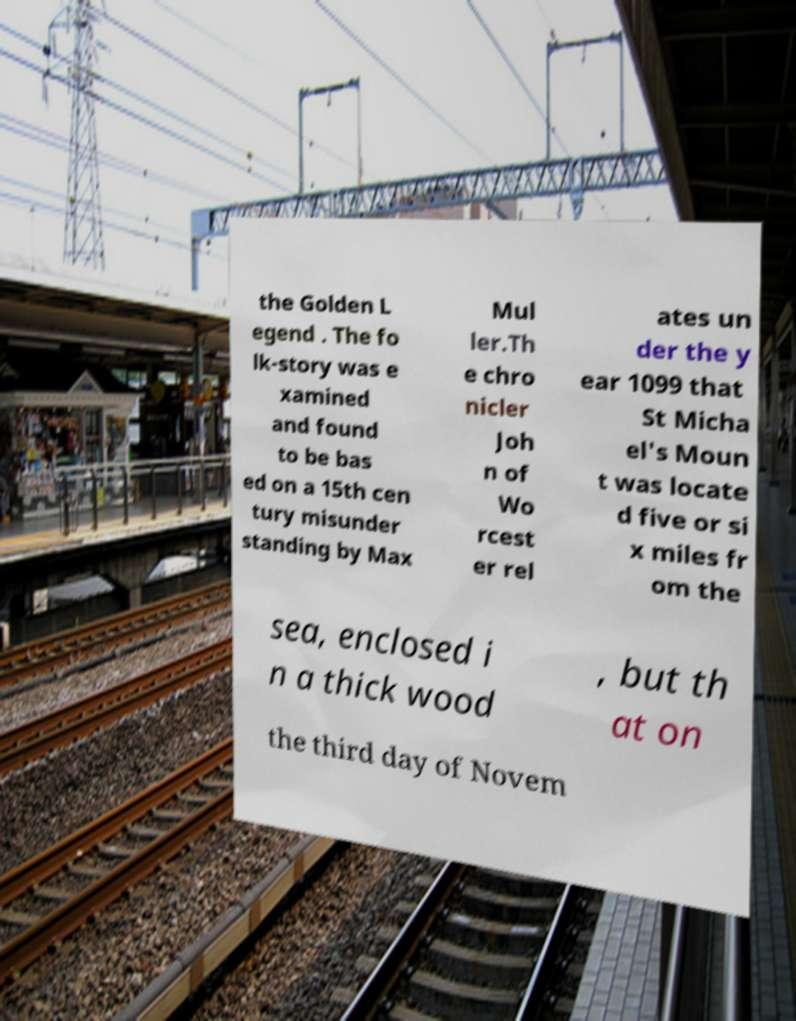There's text embedded in this image that I need extracted. Can you transcribe it verbatim? the Golden L egend . The fo lk-story was e xamined and found to be bas ed on a 15th cen tury misunder standing by Max Mul ler.Th e chro nicler Joh n of Wo rcest er rel ates un der the y ear 1099 that St Micha el's Moun t was locate d five or si x miles fr om the sea, enclosed i n a thick wood , but th at on the third day of Novem 